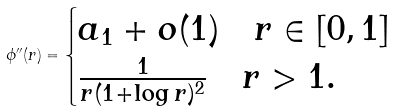<formula> <loc_0><loc_0><loc_500><loc_500>\phi ^ { \prime \prime } ( r ) = \begin{cases} a _ { 1 } + o ( 1 ) \quad r \in [ 0 , 1 ] \\ \frac { 1 } { r ( 1 + \log r ) ^ { 2 } } \quad r > 1 . \end{cases}</formula> 